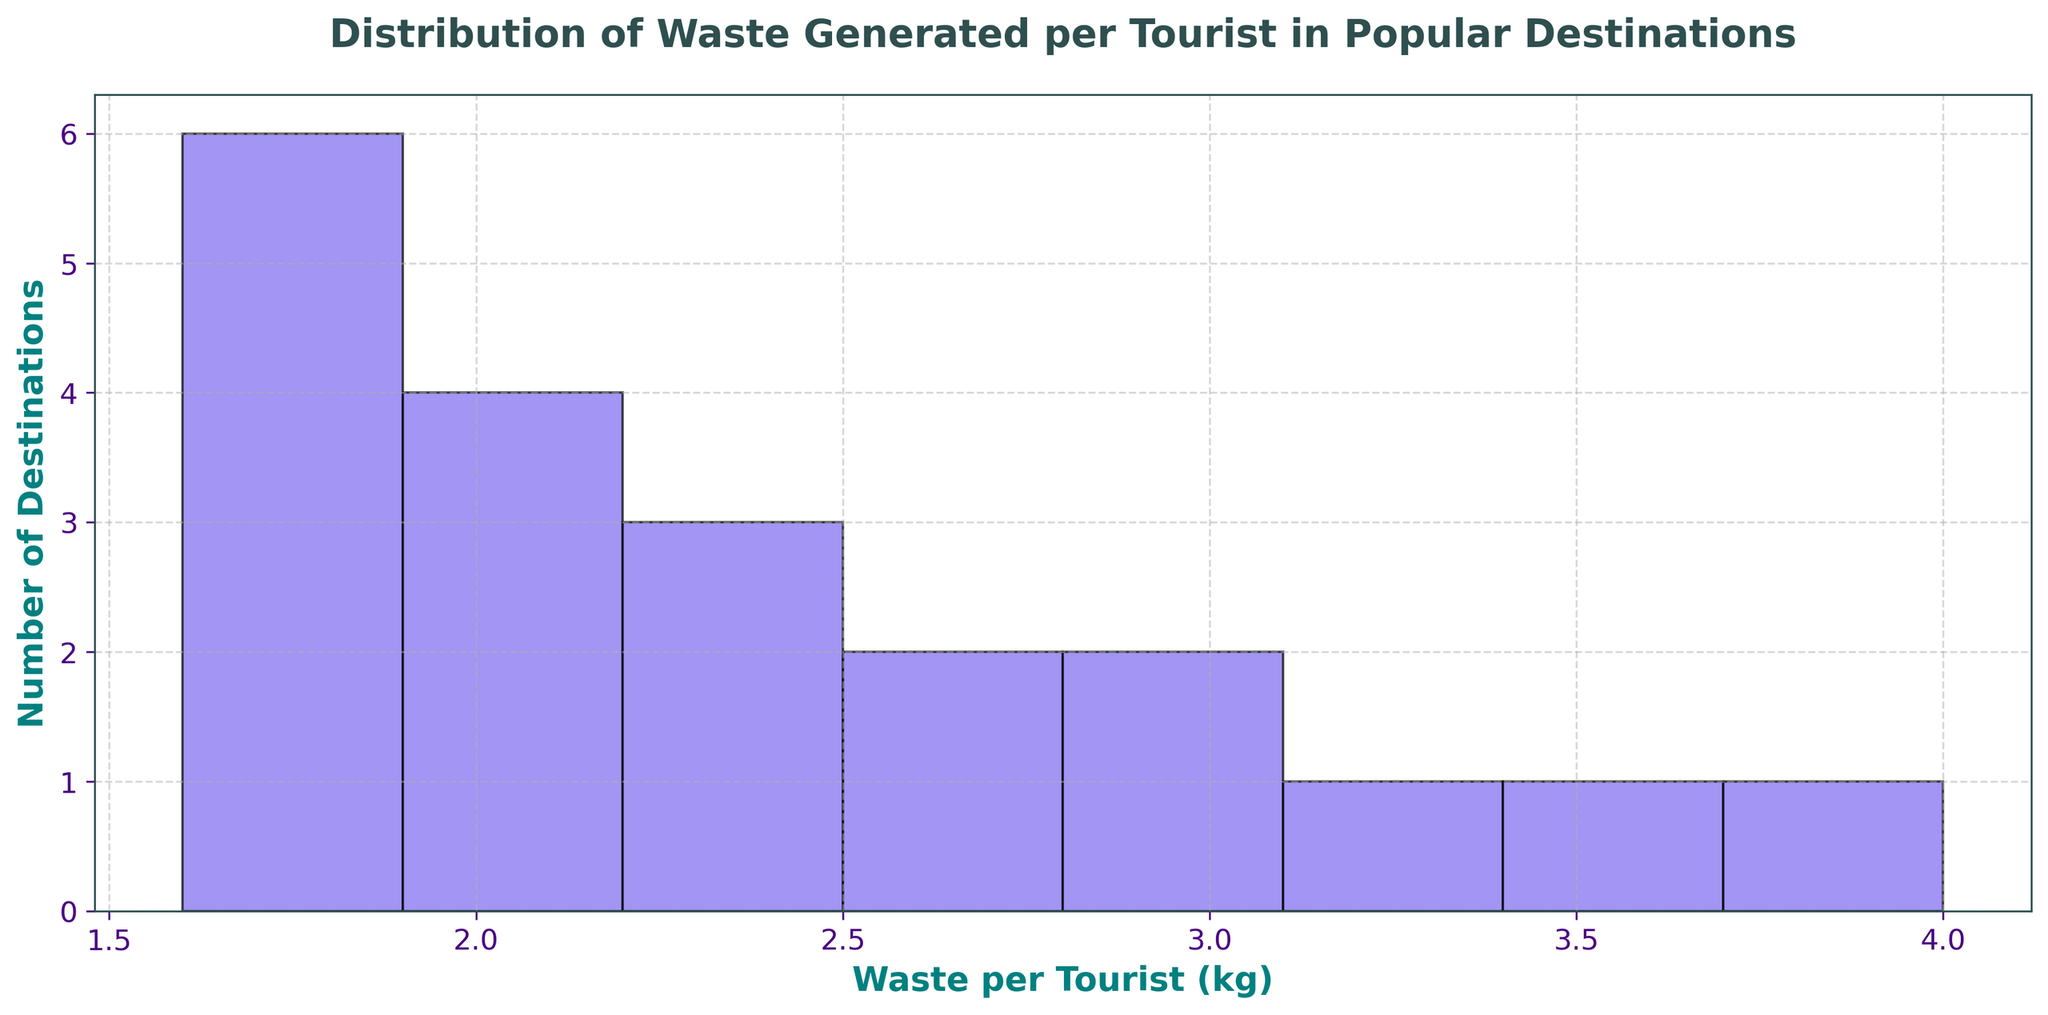What's the range of waste generated per tourist in the destinations? The range is calculated as the difference between the highest and lowest values of waste generated per tourist. From the figure, the highest is around 4.0 kg (Las Vegas) and the lowest is around 1.6 kg (Kyoto). So, the range is 4.0 kg - 1.6 kg = 2.4 kg.
Answer: 2.4 kg How many destinations generate more than 3 kg of waste per tourist? From the visual inspection of the figure, we observe the bars representing destinations generating more than 3 kg per tourist. The destinations are Bangkok, Dubai, Las Vegas, and New York. Thus, there are 4 destinations in total.
Answer: 4 Which waste per tourist category has the highest number of destinations? Looking at the histogram, we see that the category around 1.8 kg has the highest bar, indicating that more destinations fall around this value. Thus, 1.8 kg is the category with the highest number.
Answer: Around 1.8 kg What is the median waste generated per tourist in the destinations? To find the median, we need to sort the values and identify the middle one. Arranging the waste per tourist values in ascending order and looking at the 10th and 11th values (since there are 20 values in total), we get 2.1 kg and 2.1 kg. Hence, the median waste per tourist is (2.1 + 2.1) / 2 = 2.1 kg
Answer: 2.1 kg Which destinations generate the least and most waste per tourist? By inspecting the histogram, the destination generating the least waste is Kyoto (1.6 kg), and the one generating the most is Las Vegas (4.0 kg).
Answer: Kyoto (least), Las Vegas (most) Are there more destinations generating below 2 kg or above 2.5 kg of waste per tourist? To find this, count the number of destinations below 2 kg and above 2.5 kg using the histogram. Below 2 kg: Amsterdam, Barcelona, Berlin, Kyoto, Prague, Toronto, Vienna, Zurich (8 destinations). Above 2.5 kg: Bangkok, Bali, Dubai, Las Vegas, New York, Sydney, Venice (7 destinations). More destinations generate below 2 kg.
Answer: Below 2 kg What proportion of destinations produce between 2 kg and 3 kg of waste per tourist? To determine the proportion, count the number of destinations within this range and divide by the total number of destinations. Destinations between 2 kg and 3 kg are Amsterdam, Bali, Berlin, London, Paris, Rome, Singapore, Sydney, Tokyo, Venice (10 destinations). The total number of destinations is 20. Thus, the proportion is 10/20 = 0.5
Answer: 0.5 or 50% What's the average waste generated per tourist across all the destinations? Sum all the waste per tourist values and divide by the number of destinations. Total waste = 2.1 + 1.8 + 3.2 + 2.5 + 2.0 + 3.0 + 1.6 + 4.0 + 2.3 + 3.5 + 2.4 + 1.9 + 2.2 + 2.1 + 2.7 + 2.0 + 1.8 + 2.8 + 1.7 + 1.8 = 52.4 kg. Average = 52.4 kg / 20 = 2.62 kg
Answer: 2.62 kg 